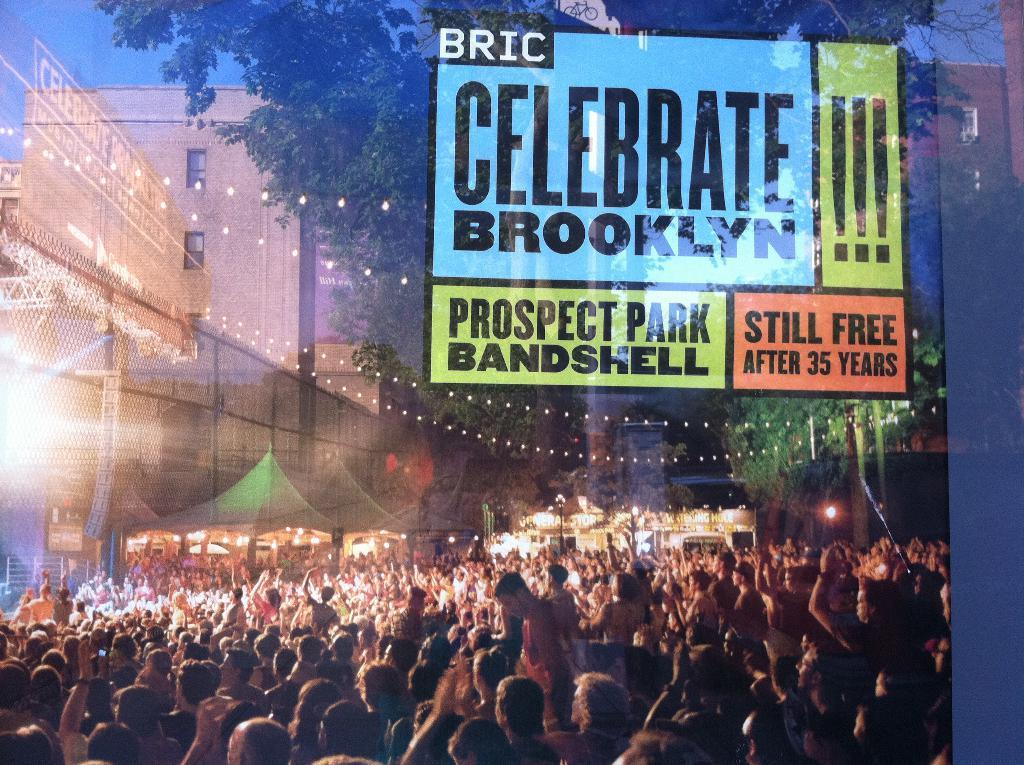Provide a one-sentence caption for the provided image. A group of people that are out celebrating brooklyn one afternoon. 